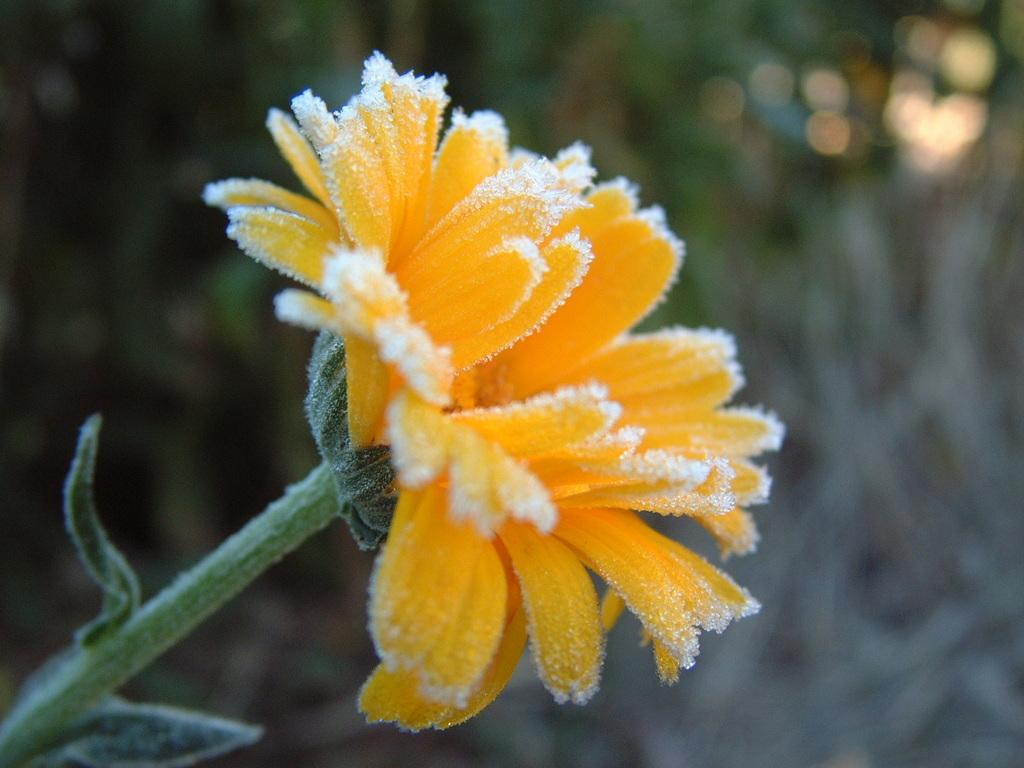What type of plant can be seen in the image? There is a yellow flower in the image. What other parts of the plant are visible? There are leaves and a stem in the image. How would you describe the background of the image? The background of the image is blurry. What is the price of the faucet in the image? There is no faucet present in the image, so it is not possible to determine its price. 